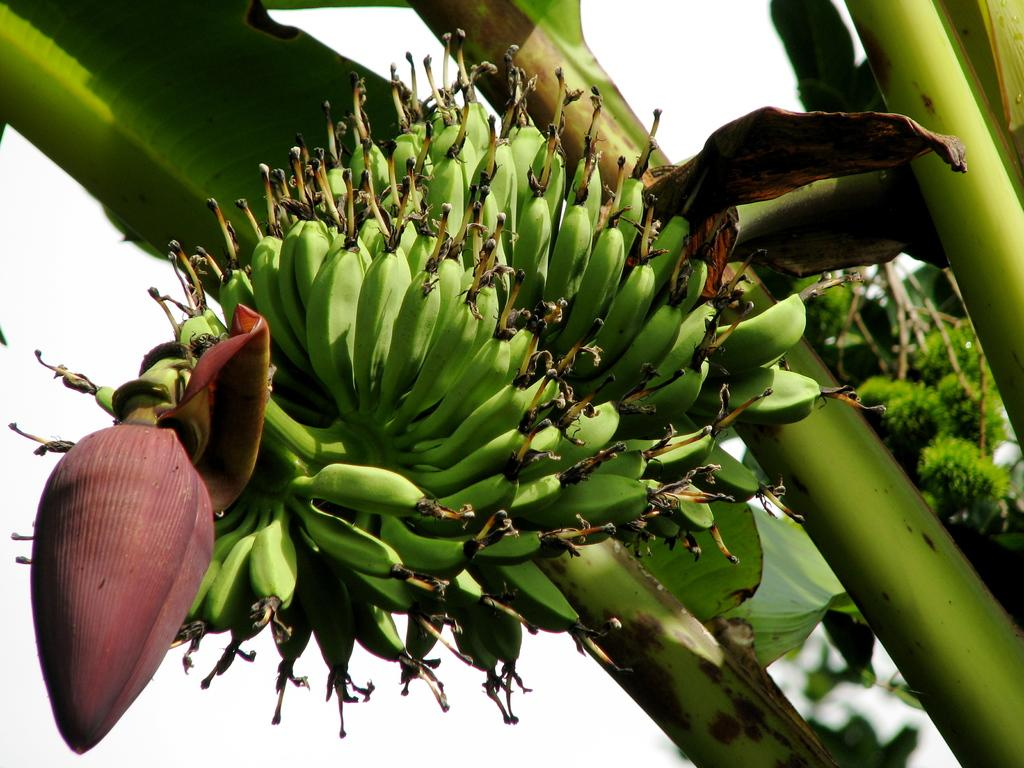What type of tree is visible in the image? There is a banana tree in the image. What is hanging from the tree in the image? A bunch of bananas is present in the image. What other part of the banana tree can be seen in the image? There is a banana flower in the image. How many ideas can be seen in the basket in the image? There is no basket or ideas present in the image. 